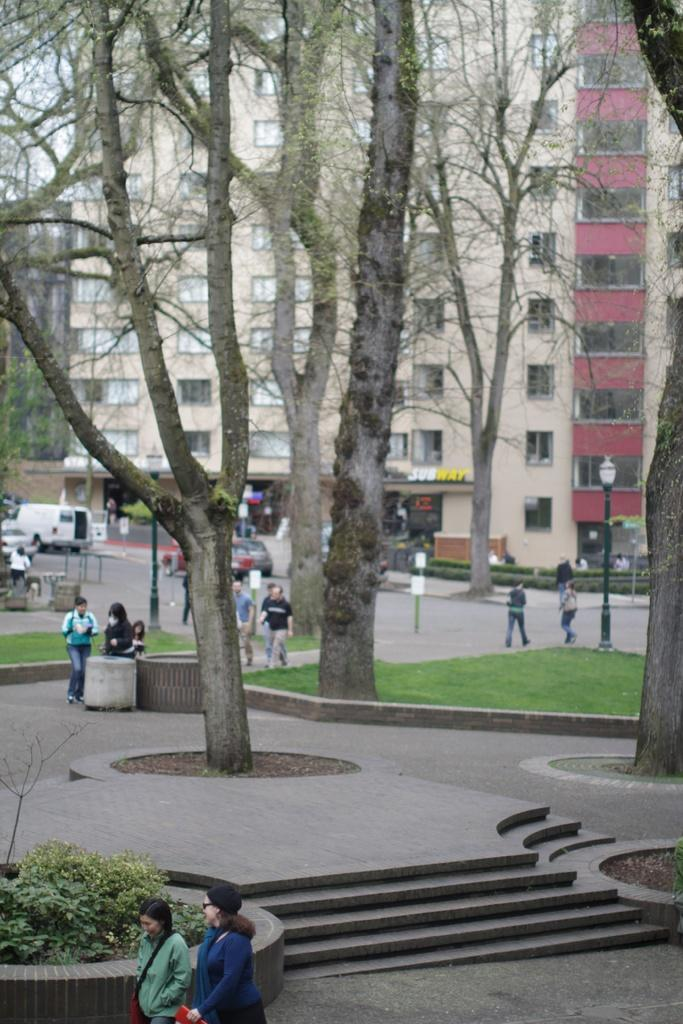What type of vegetation can be seen in the image? There are trees in the image. What are the people in the image doing? The people are on a walkway in the image. What can be seen moving on the road in the image? Vehicles are visible on the road in the image. What type of structures are present in the image? There are buildings in the image. What is the tall, vertical object near the walkway? A light pole is present in the image. What architectural feature is visible in the image? There is a staircase in the image. What type of produce is being sold at the sign in the image? There is no sign or produce present in the image. What word is written on the sign in the image? There is no sign or word present in the image. 